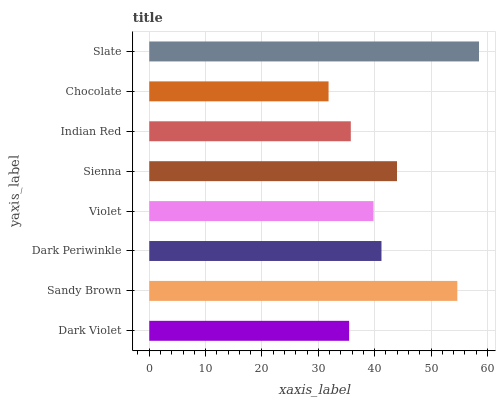Is Chocolate the minimum?
Answer yes or no. Yes. Is Slate the maximum?
Answer yes or no. Yes. Is Sandy Brown the minimum?
Answer yes or no. No. Is Sandy Brown the maximum?
Answer yes or no. No. Is Sandy Brown greater than Dark Violet?
Answer yes or no. Yes. Is Dark Violet less than Sandy Brown?
Answer yes or no. Yes. Is Dark Violet greater than Sandy Brown?
Answer yes or no. No. Is Sandy Brown less than Dark Violet?
Answer yes or no. No. Is Dark Periwinkle the high median?
Answer yes or no. Yes. Is Violet the low median?
Answer yes or no. Yes. Is Slate the high median?
Answer yes or no. No. Is Sienna the low median?
Answer yes or no. No. 